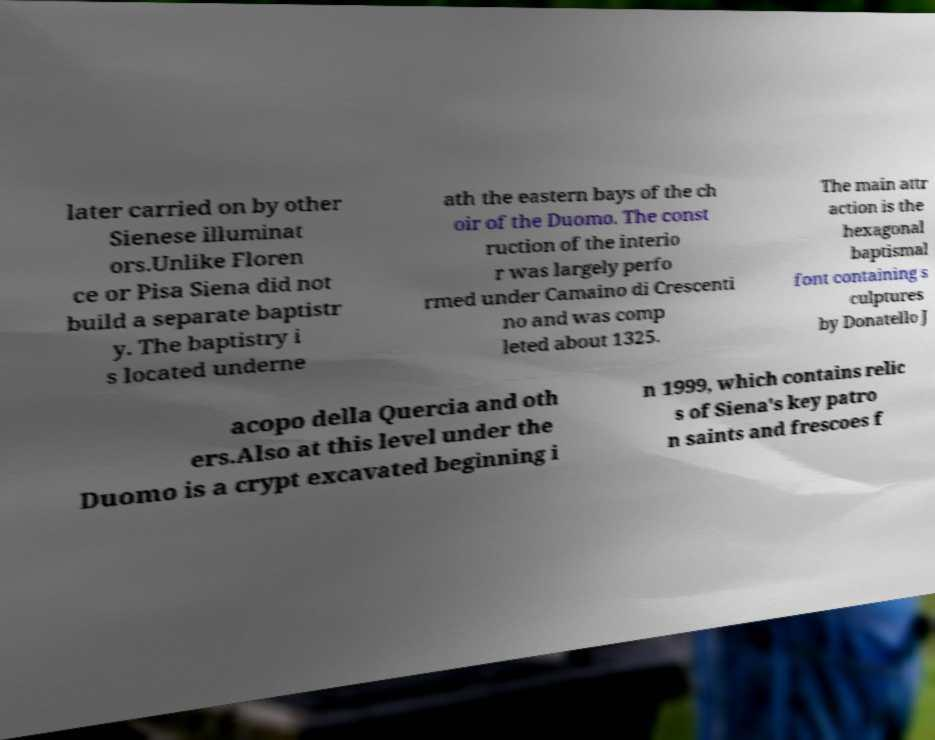Can you read and provide the text displayed in the image?This photo seems to have some interesting text. Can you extract and type it out for me? later carried on by other Sienese illuminat ors.Unlike Floren ce or Pisa Siena did not build a separate baptistr y. The baptistry i s located underne ath the eastern bays of the ch oir of the Duomo. The const ruction of the interio r was largely perfo rmed under Camaino di Crescenti no and was comp leted about 1325. The main attr action is the hexagonal baptismal font containing s culptures by Donatello J acopo della Quercia and oth ers.Also at this level under the Duomo is a crypt excavated beginning i n 1999, which contains relic s of Siena's key patro n saints and frescoes f 